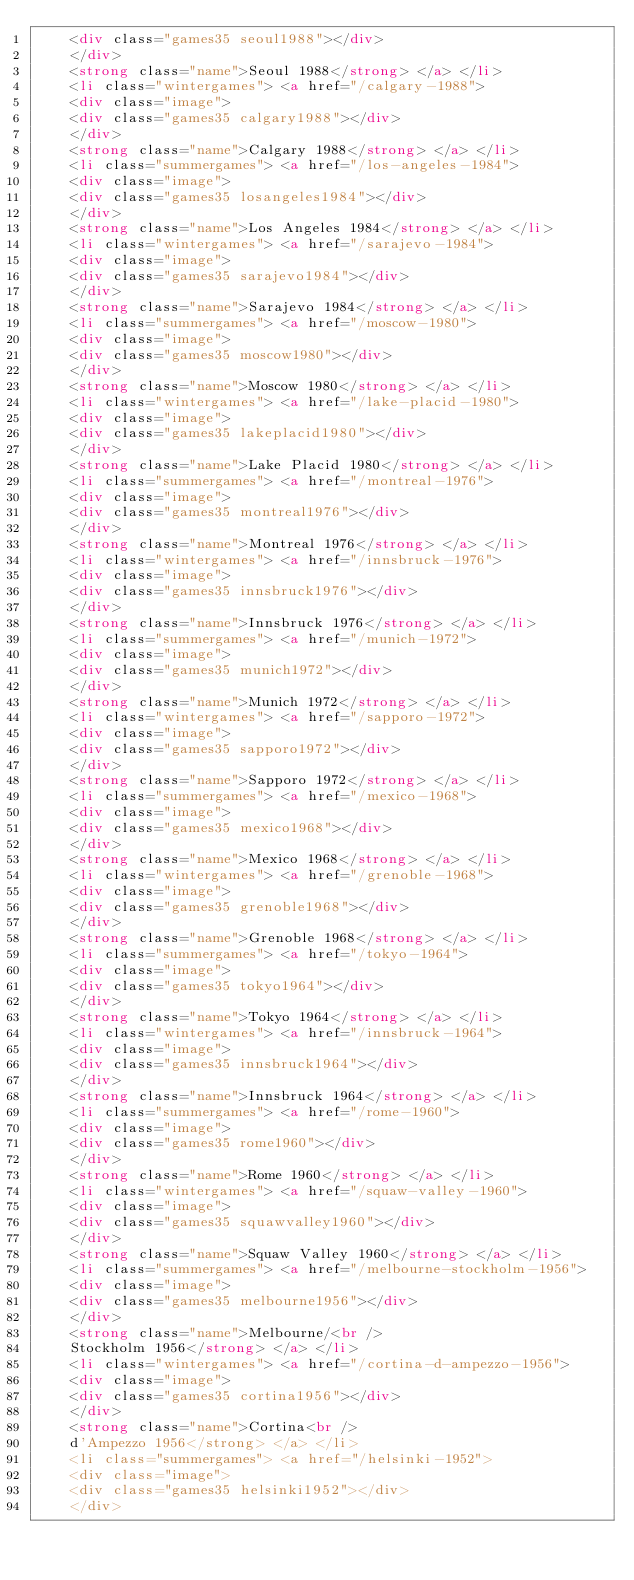Convert code to text. <code><loc_0><loc_0><loc_500><loc_500><_HTML_>    <div class="games35 seoul1988"></div>
    </div>
    <strong class="name">Seoul 1988</strong> </a> </li>
    <li class="wintergames"> <a href="/calgary-1988">
    <div class="image">
    <div class="games35 calgary1988"></div>
    </div>
    <strong class="name">Calgary 1988</strong> </a> </li>
    <li class="summergames"> <a href="/los-angeles-1984">
    <div class="image">
    <div class="games35 losangeles1984"></div>
    </div>
    <strong class="name">Los Angeles 1984</strong> </a> </li>
    <li class="wintergames"> <a href="/sarajevo-1984">
    <div class="image">
    <div class="games35 sarajevo1984"></div>
    </div>
    <strong class="name">Sarajevo 1984</strong> </a> </li>
    <li class="summergames"> <a href="/moscow-1980">
    <div class="image">
    <div class="games35 moscow1980"></div>
    </div>
    <strong class="name">Moscow 1980</strong> </a> </li>
    <li class="wintergames"> <a href="/lake-placid-1980">
    <div class="image">
    <div class="games35 lakeplacid1980"></div>
    </div>
    <strong class="name">Lake Placid 1980</strong> </a> </li>
    <li class="summergames"> <a href="/montreal-1976">
    <div class="image">
    <div class="games35 montreal1976"></div>
    </div>
    <strong class="name">Montreal 1976</strong> </a> </li>
    <li class="wintergames"> <a href="/innsbruck-1976">
    <div class="image">
    <div class="games35 innsbruck1976"></div>
    </div>
    <strong class="name">Innsbruck 1976</strong> </a> </li>
    <li class="summergames"> <a href="/munich-1972">
    <div class="image">
    <div class="games35 munich1972"></div>
    </div>
    <strong class="name">Munich 1972</strong> </a> </li>
    <li class="wintergames"> <a href="/sapporo-1972">
    <div class="image">
    <div class="games35 sapporo1972"></div>
    </div>
    <strong class="name">Sapporo 1972</strong> </a> </li>
    <li class="summergames"> <a href="/mexico-1968">
    <div class="image">
    <div class="games35 mexico1968"></div>
    </div>
    <strong class="name">Mexico 1968</strong> </a> </li>
    <li class="wintergames"> <a href="/grenoble-1968">
    <div class="image">
    <div class="games35 grenoble1968"></div>
    </div>
    <strong class="name">Grenoble 1968</strong> </a> </li>
    <li class="summergames"> <a href="/tokyo-1964">
    <div class="image">
    <div class="games35 tokyo1964"></div>
    </div>
    <strong class="name">Tokyo 1964</strong> </a> </li>
    <li class="wintergames"> <a href="/innsbruck-1964">
    <div class="image">
    <div class="games35 innsbruck1964"></div>
    </div>
    <strong class="name">Innsbruck 1964</strong> </a> </li>
    <li class="summergames"> <a href="/rome-1960">
    <div class="image">
    <div class="games35 rome1960"></div>
    </div>
    <strong class="name">Rome 1960</strong> </a> </li>
    <li class="wintergames"> <a href="/squaw-valley-1960">
    <div class="image">
    <div class="games35 squawvalley1960"></div>
    </div>
    <strong class="name">Squaw Valley 1960</strong> </a> </li>
    <li class="summergames"> <a href="/melbourne-stockholm-1956">
    <div class="image">
    <div class="games35 melbourne1956"></div>
    </div>
    <strong class="name">Melbourne/<br />
    Stockholm 1956</strong> </a> </li>
    <li class="wintergames"> <a href="/cortina-d-ampezzo-1956">
    <div class="image">
    <div class="games35 cortina1956"></div>
    </div>
    <strong class="name">Cortina<br />
    d'Ampezzo 1956</strong> </a> </li>
    <li class="summergames"> <a href="/helsinki-1952">
    <div class="image">
    <div class="games35 helsinki1952"></div>
    </div></code> 